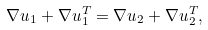<formula> <loc_0><loc_0><loc_500><loc_500>\nabla u _ { 1 } + \nabla u _ { 1 } ^ { T } = \nabla u _ { 2 } + \nabla u _ { 2 } ^ { T } ,</formula> 